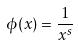<formula> <loc_0><loc_0><loc_500><loc_500>\phi ( x ) = \frac { 1 } { x ^ { s } }</formula> 